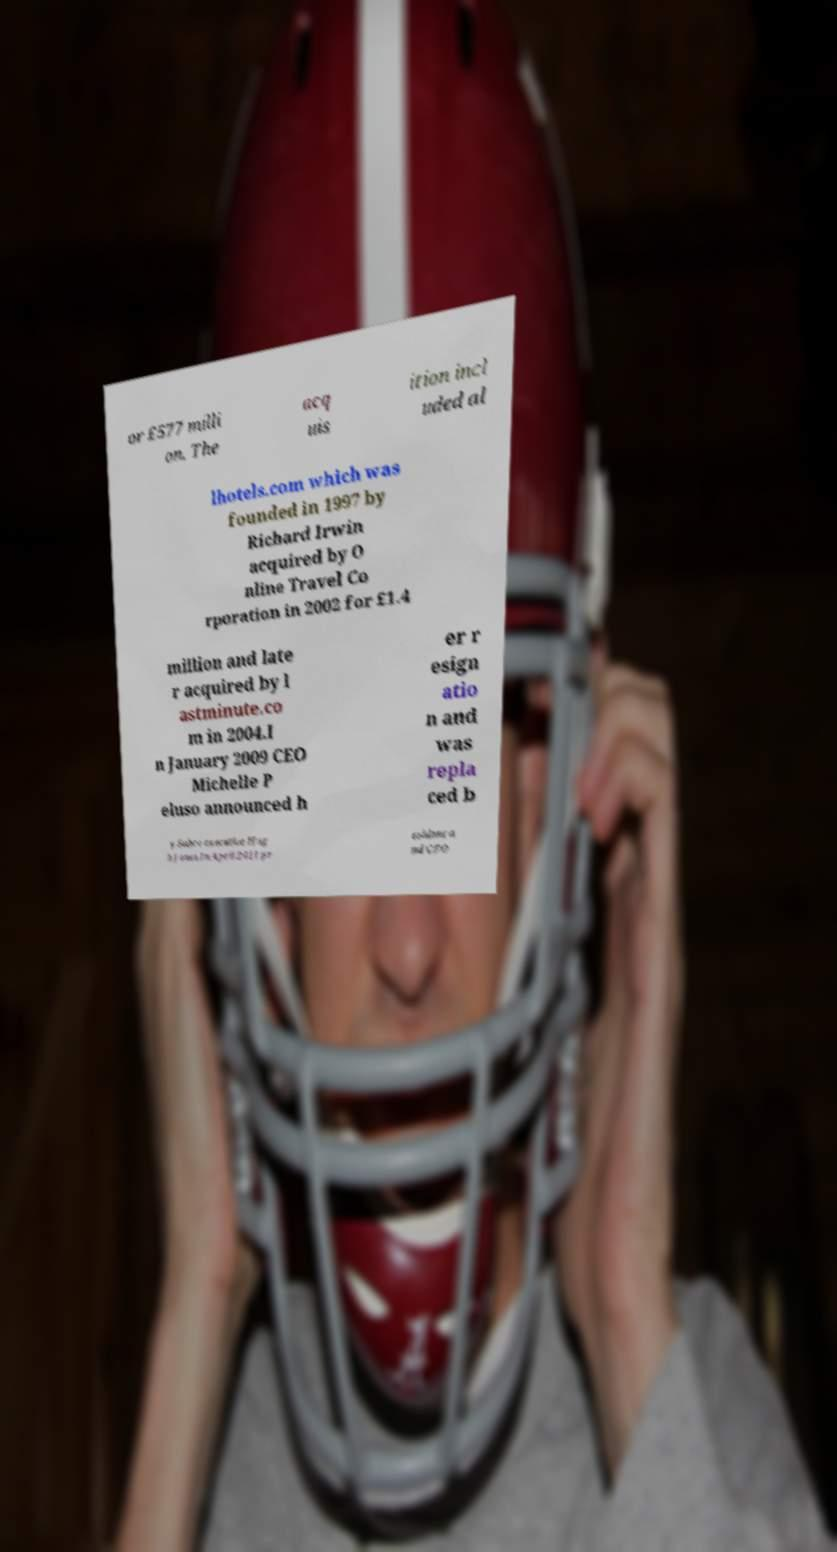Please read and relay the text visible in this image. What does it say? or £577 milli on. The acq uis ition incl uded al lhotels.com which was founded in 1997 by Richard Irwin acquired by O nline Travel Co rporation in 2002 for £1.4 million and late r acquired by l astminute.co m in 2004.I n January 2009 CEO Michelle P eluso announced h er r esign atio n and was repla ced b y Sabre executive Hug h Jones.In April 2011 pr esident a nd CEO 